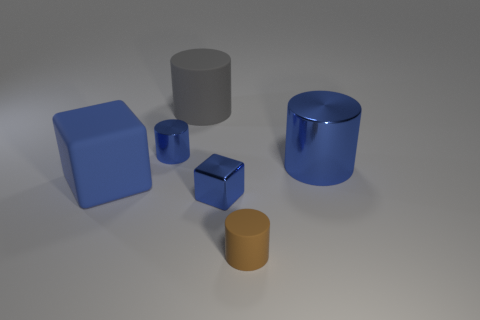Add 1 large blue matte blocks. How many objects exist? 7 Subtract all cubes. How many objects are left? 4 Subtract all big cylinders. Subtract all large gray matte cylinders. How many objects are left? 3 Add 1 big blue objects. How many big blue objects are left? 3 Add 4 tiny metallic blocks. How many tiny metallic blocks exist? 5 Subtract 0 blue balls. How many objects are left? 6 